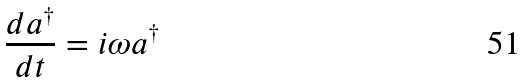Convert formula to latex. <formula><loc_0><loc_0><loc_500><loc_500>\frac { d a ^ { \dagger } } { d t } = i \omega a ^ { \dagger }</formula> 